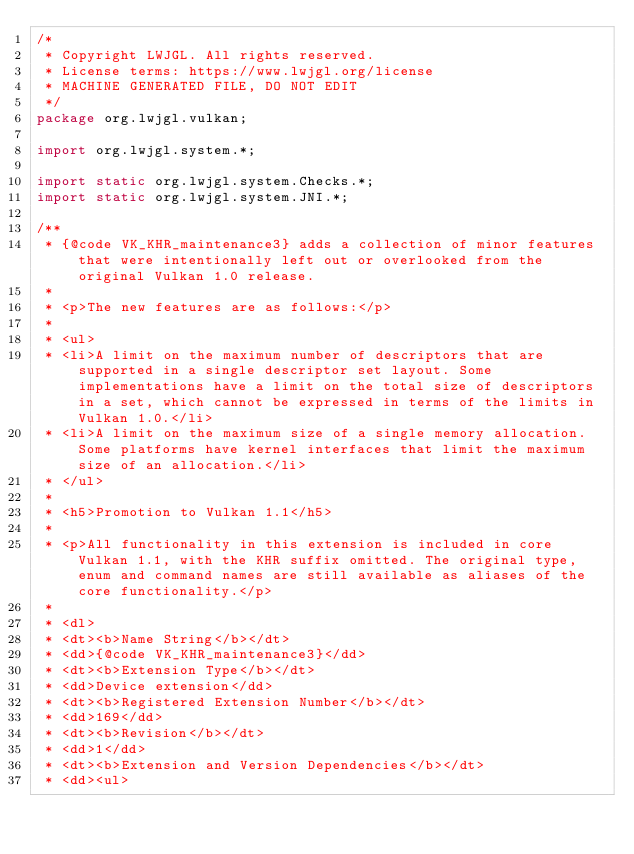Convert code to text. <code><loc_0><loc_0><loc_500><loc_500><_Java_>/*
 * Copyright LWJGL. All rights reserved.
 * License terms: https://www.lwjgl.org/license
 * MACHINE GENERATED FILE, DO NOT EDIT
 */
package org.lwjgl.vulkan;

import org.lwjgl.system.*;

import static org.lwjgl.system.Checks.*;
import static org.lwjgl.system.JNI.*;

/**
 * {@code VK_KHR_maintenance3} adds a collection of minor features that were intentionally left out or overlooked from the original Vulkan 1.0 release.
 * 
 * <p>The new features are as follows:</p>
 * 
 * <ul>
 * <li>A limit on the maximum number of descriptors that are supported in a single descriptor set layout. Some implementations have a limit on the total size of descriptors in a set, which cannot be expressed in terms of the limits in Vulkan 1.0.</li>
 * <li>A limit on the maximum size of a single memory allocation. Some platforms have kernel interfaces that limit the maximum size of an allocation.</li>
 * </ul>
 * 
 * <h5>Promotion to Vulkan 1.1</h5>
 * 
 * <p>All functionality in this extension is included in core Vulkan 1.1, with the KHR suffix omitted. The original type, enum and command names are still available as aliases of the core functionality.</p>
 * 
 * <dl>
 * <dt><b>Name String</b></dt>
 * <dd>{@code VK_KHR_maintenance3}</dd>
 * <dt><b>Extension Type</b></dt>
 * <dd>Device extension</dd>
 * <dt><b>Registered Extension Number</b></dt>
 * <dd>169</dd>
 * <dt><b>Revision</b></dt>
 * <dd>1</dd>
 * <dt><b>Extension and Version Dependencies</b></dt>
 * <dd><ul></code> 